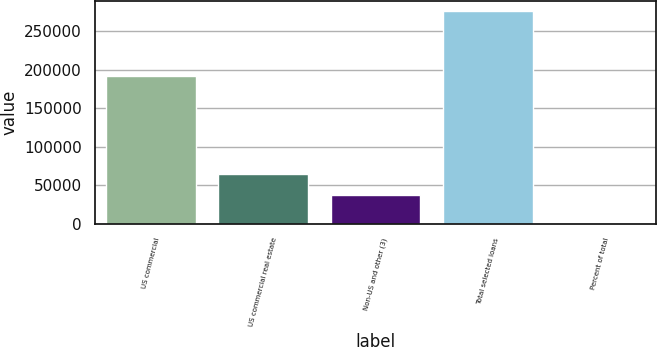<chart> <loc_0><loc_0><loc_500><loc_500><bar_chart><fcel>US commercial<fcel>US commercial real estate<fcel>Non-US and other (3)<fcel>Total selected loans<fcel>Percent of total<nl><fcel>191878<fcel>65212.7<fcel>37581<fcel>276417<fcel>100<nl></chart> 